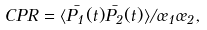Convert formula to latex. <formula><loc_0><loc_0><loc_500><loc_500>C P R = \langle \bar { P _ { 1 } } ( t ) \bar { P _ { 2 } } ( t ) \rangle / \sigma _ { 1 } \sigma _ { 2 } ,</formula> 